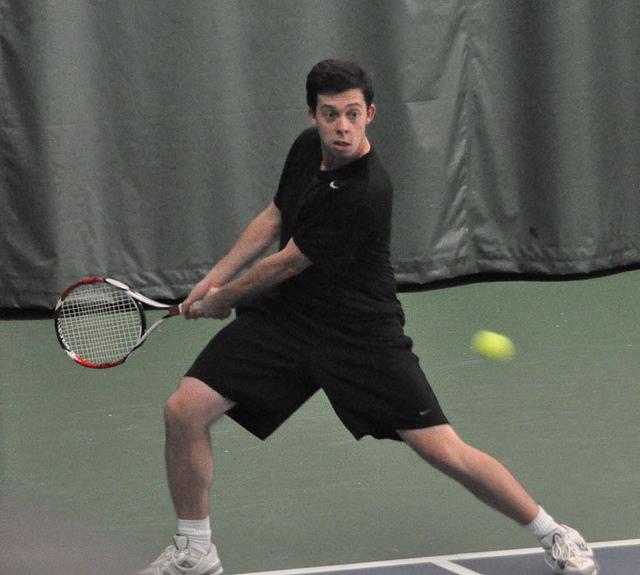What color are the man's sneakers?
Quick response, please. White. Did this person just hit the ball a split second ago?
Be succinct. No. How many hands are on the racket?
Concise answer only. 2. 